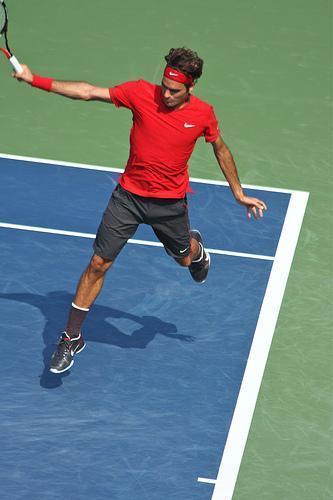How many people are playing tennis?
Give a very brief answer. 1. How many players are there?
Give a very brief answer. 1. How many people are playing football?
Give a very brief answer. 0. 